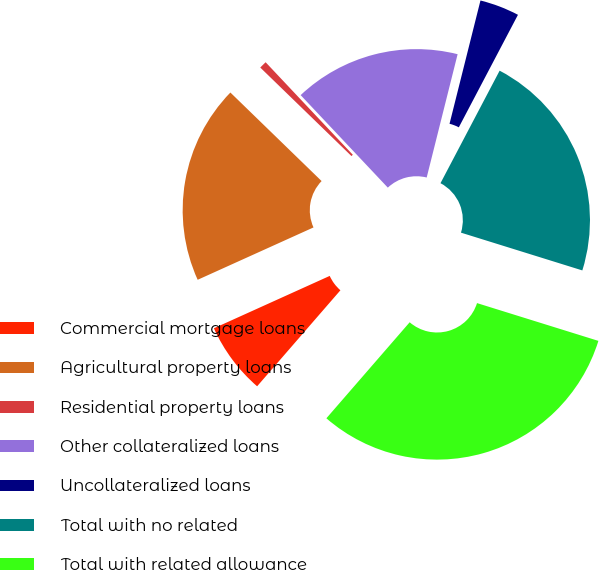Convert chart. <chart><loc_0><loc_0><loc_500><loc_500><pie_chart><fcel>Commercial mortgage loans<fcel>Agricultural property loans<fcel>Residential property loans<fcel>Other collateralized loans<fcel>Uncollateralized loans<fcel>Total with no related<fcel>Total with related allowance<nl><fcel>6.87%<fcel>19.02%<fcel>0.71%<fcel>15.94%<fcel>3.79%<fcel>22.1%<fcel>31.57%<nl></chart> 